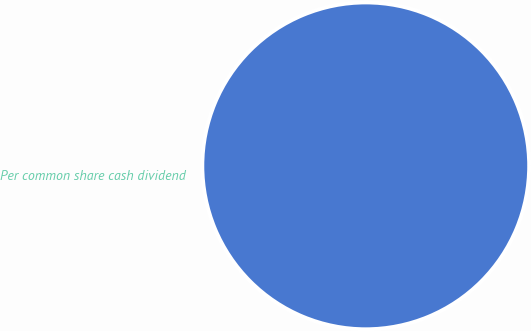<chart> <loc_0><loc_0><loc_500><loc_500><pie_chart><fcel>Per common share cash dividend<nl><fcel>100.0%<nl></chart> 